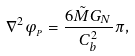<formula> <loc_0><loc_0><loc_500><loc_500>\nabla ^ { 2 } \varphi _ { _ { P } } = \frac { 6 \tilde { M } G _ { N } } { C _ { b } ^ { 2 } } \pi ,</formula> 